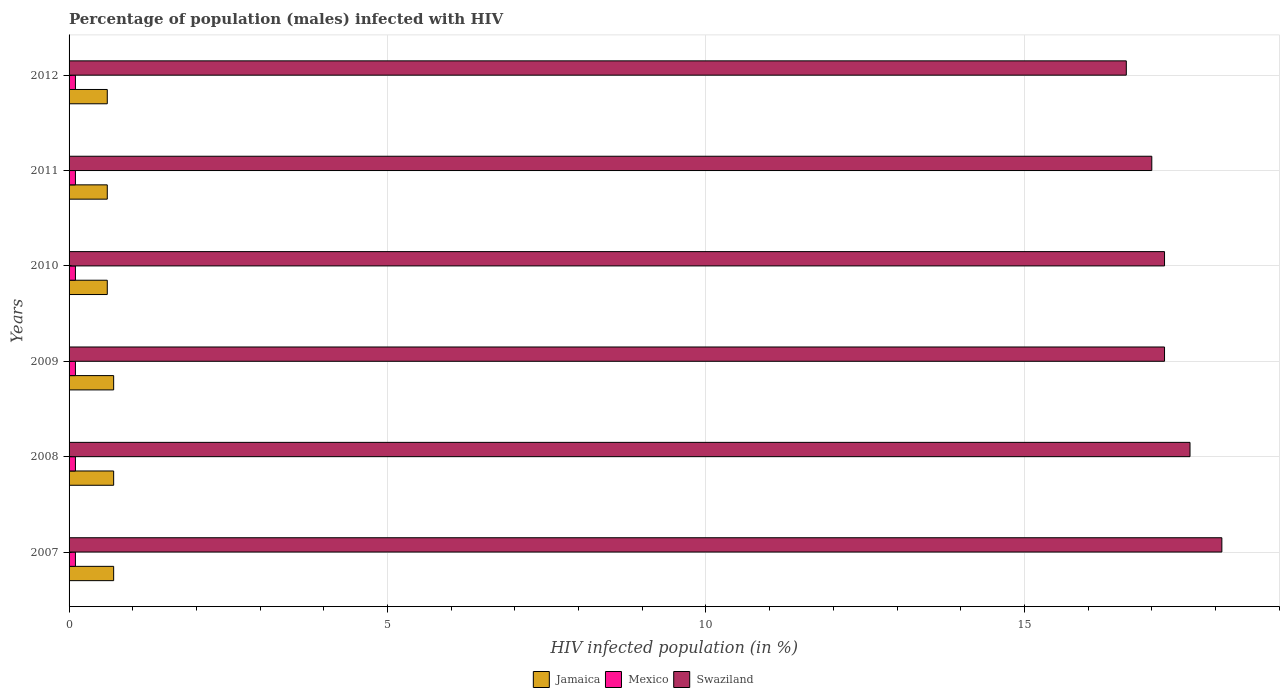How many different coloured bars are there?
Ensure brevity in your answer.  3. Are the number of bars per tick equal to the number of legend labels?
Your answer should be very brief. Yes. How many bars are there on the 2nd tick from the bottom?
Make the answer very short. 3. What is the label of the 5th group of bars from the top?
Offer a terse response. 2008. What is the percentage of HIV infected male population in Mexico in 2007?
Ensure brevity in your answer.  0.1. In which year was the percentage of HIV infected male population in Jamaica minimum?
Make the answer very short. 2010. What is the total percentage of HIV infected male population in Swaziland in the graph?
Make the answer very short. 103.7. What is the difference between the percentage of HIV infected male population in Swaziland in 2011 and that in 2012?
Keep it short and to the point. 0.4. What is the difference between the percentage of HIV infected male population in Jamaica in 2007 and the percentage of HIV infected male population in Mexico in 2012?
Give a very brief answer. 0.6. What is the average percentage of HIV infected male population in Jamaica per year?
Offer a very short reply. 0.65. In the year 2010, what is the difference between the percentage of HIV infected male population in Swaziland and percentage of HIV infected male population in Jamaica?
Ensure brevity in your answer.  16.6. What is the ratio of the percentage of HIV infected male population in Jamaica in 2009 to that in 2011?
Provide a succinct answer. 1.17. Is the percentage of HIV infected male population in Mexico in 2008 less than that in 2012?
Your answer should be very brief. No. Is the difference between the percentage of HIV infected male population in Swaziland in 2007 and 2009 greater than the difference between the percentage of HIV infected male population in Jamaica in 2007 and 2009?
Your response must be concise. Yes. What is the difference between the highest and the lowest percentage of HIV infected male population in Jamaica?
Provide a short and direct response. 0.1. In how many years, is the percentage of HIV infected male population in Swaziland greater than the average percentage of HIV infected male population in Swaziland taken over all years?
Offer a terse response. 2. What does the 3rd bar from the top in 2012 represents?
Ensure brevity in your answer.  Jamaica. What does the 3rd bar from the bottom in 2010 represents?
Give a very brief answer. Swaziland. Is it the case that in every year, the sum of the percentage of HIV infected male population in Swaziland and percentage of HIV infected male population in Mexico is greater than the percentage of HIV infected male population in Jamaica?
Offer a very short reply. Yes. Are all the bars in the graph horizontal?
Your answer should be very brief. Yes. What is the difference between two consecutive major ticks on the X-axis?
Provide a succinct answer. 5. Does the graph contain any zero values?
Keep it short and to the point. No. Does the graph contain grids?
Your answer should be very brief. Yes. What is the title of the graph?
Offer a very short reply. Percentage of population (males) infected with HIV. Does "Korea (Democratic)" appear as one of the legend labels in the graph?
Ensure brevity in your answer.  No. What is the label or title of the X-axis?
Keep it short and to the point. HIV infected population (in %). What is the HIV infected population (in %) in Jamaica in 2007?
Offer a very short reply. 0.7. What is the HIV infected population (in %) in Swaziland in 2007?
Provide a succinct answer. 18.1. What is the HIV infected population (in %) in Mexico in 2008?
Your answer should be compact. 0.1. What is the HIV infected population (in %) in Swaziland in 2008?
Provide a short and direct response. 17.6. What is the HIV infected population (in %) of Mexico in 2009?
Your answer should be very brief. 0.1. What is the HIV infected population (in %) of Jamaica in 2010?
Offer a terse response. 0.6. What is the HIV infected population (in %) in Swaziland in 2010?
Your answer should be compact. 17.2. What is the HIV infected population (in %) in Jamaica in 2011?
Keep it short and to the point. 0.6. What is the HIV infected population (in %) in Mexico in 2011?
Your answer should be compact. 0.1. What is the HIV infected population (in %) of Jamaica in 2012?
Offer a very short reply. 0.6. What is the HIV infected population (in %) in Mexico in 2012?
Your response must be concise. 0.1. Across all years, what is the maximum HIV infected population (in %) in Jamaica?
Your response must be concise. 0.7. Across all years, what is the maximum HIV infected population (in %) in Swaziland?
Provide a short and direct response. 18.1. Across all years, what is the minimum HIV infected population (in %) of Jamaica?
Ensure brevity in your answer.  0.6. Across all years, what is the minimum HIV infected population (in %) in Mexico?
Offer a terse response. 0.1. Across all years, what is the minimum HIV infected population (in %) of Swaziland?
Keep it short and to the point. 16.6. What is the total HIV infected population (in %) in Jamaica in the graph?
Make the answer very short. 3.9. What is the total HIV infected population (in %) of Mexico in the graph?
Provide a short and direct response. 0.6. What is the total HIV infected population (in %) of Swaziland in the graph?
Give a very brief answer. 103.7. What is the difference between the HIV infected population (in %) in Mexico in 2007 and that in 2008?
Your response must be concise. 0. What is the difference between the HIV infected population (in %) of Swaziland in 2007 and that in 2009?
Make the answer very short. 0.9. What is the difference between the HIV infected population (in %) in Jamaica in 2007 and that in 2010?
Give a very brief answer. 0.1. What is the difference between the HIV infected population (in %) in Jamaica in 2007 and that in 2012?
Keep it short and to the point. 0.1. What is the difference between the HIV infected population (in %) of Swaziland in 2008 and that in 2009?
Your answer should be very brief. 0.4. What is the difference between the HIV infected population (in %) in Mexico in 2008 and that in 2010?
Offer a very short reply. 0. What is the difference between the HIV infected population (in %) of Swaziland in 2008 and that in 2010?
Your answer should be very brief. 0.4. What is the difference between the HIV infected population (in %) in Jamaica in 2008 and that in 2011?
Offer a terse response. 0.1. What is the difference between the HIV infected population (in %) in Mexico in 2008 and that in 2011?
Keep it short and to the point. 0. What is the difference between the HIV infected population (in %) in Jamaica in 2008 and that in 2012?
Give a very brief answer. 0.1. What is the difference between the HIV infected population (in %) of Mexico in 2008 and that in 2012?
Keep it short and to the point. 0. What is the difference between the HIV infected population (in %) of Swaziland in 2009 and that in 2010?
Provide a short and direct response. 0. What is the difference between the HIV infected population (in %) in Jamaica in 2009 and that in 2011?
Offer a terse response. 0.1. What is the difference between the HIV infected population (in %) of Swaziland in 2009 and that in 2011?
Ensure brevity in your answer.  0.2. What is the difference between the HIV infected population (in %) in Mexico in 2010 and that in 2011?
Offer a terse response. 0. What is the difference between the HIV infected population (in %) of Swaziland in 2010 and that in 2011?
Your answer should be compact. 0.2. What is the difference between the HIV infected population (in %) in Jamaica in 2010 and that in 2012?
Provide a short and direct response. 0. What is the difference between the HIV infected population (in %) of Swaziland in 2010 and that in 2012?
Give a very brief answer. 0.6. What is the difference between the HIV infected population (in %) in Jamaica in 2011 and that in 2012?
Ensure brevity in your answer.  0. What is the difference between the HIV infected population (in %) of Jamaica in 2007 and the HIV infected population (in %) of Mexico in 2008?
Offer a very short reply. 0.6. What is the difference between the HIV infected population (in %) in Jamaica in 2007 and the HIV infected population (in %) in Swaziland in 2008?
Your response must be concise. -16.9. What is the difference between the HIV infected population (in %) in Mexico in 2007 and the HIV infected population (in %) in Swaziland in 2008?
Make the answer very short. -17.5. What is the difference between the HIV infected population (in %) in Jamaica in 2007 and the HIV infected population (in %) in Swaziland in 2009?
Ensure brevity in your answer.  -16.5. What is the difference between the HIV infected population (in %) of Mexico in 2007 and the HIV infected population (in %) of Swaziland in 2009?
Offer a very short reply. -17.1. What is the difference between the HIV infected population (in %) in Jamaica in 2007 and the HIV infected population (in %) in Mexico in 2010?
Keep it short and to the point. 0.6. What is the difference between the HIV infected population (in %) of Jamaica in 2007 and the HIV infected population (in %) of Swaziland in 2010?
Give a very brief answer. -16.5. What is the difference between the HIV infected population (in %) in Mexico in 2007 and the HIV infected population (in %) in Swaziland in 2010?
Provide a succinct answer. -17.1. What is the difference between the HIV infected population (in %) of Jamaica in 2007 and the HIV infected population (in %) of Mexico in 2011?
Your response must be concise. 0.6. What is the difference between the HIV infected population (in %) in Jamaica in 2007 and the HIV infected population (in %) in Swaziland in 2011?
Keep it short and to the point. -16.3. What is the difference between the HIV infected population (in %) in Mexico in 2007 and the HIV infected population (in %) in Swaziland in 2011?
Offer a very short reply. -16.9. What is the difference between the HIV infected population (in %) of Jamaica in 2007 and the HIV infected population (in %) of Mexico in 2012?
Give a very brief answer. 0.6. What is the difference between the HIV infected population (in %) of Jamaica in 2007 and the HIV infected population (in %) of Swaziland in 2012?
Make the answer very short. -15.9. What is the difference between the HIV infected population (in %) of Mexico in 2007 and the HIV infected population (in %) of Swaziland in 2012?
Your answer should be very brief. -16.5. What is the difference between the HIV infected population (in %) in Jamaica in 2008 and the HIV infected population (in %) in Swaziland in 2009?
Offer a very short reply. -16.5. What is the difference between the HIV infected population (in %) of Mexico in 2008 and the HIV infected population (in %) of Swaziland in 2009?
Keep it short and to the point. -17.1. What is the difference between the HIV infected population (in %) in Jamaica in 2008 and the HIV infected population (in %) in Mexico in 2010?
Ensure brevity in your answer.  0.6. What is the difference between the HIV infected population (in %) of Jamaica in 2008 and the HIV infected population (in %) of Swaziland in 2010?
Offer a very short reply. -16.5. What is the difference between the HIV infected population (in %) of Mexico in 2008 and the HIV infected population (in %) of Swaziland in 2010?
Provide a short and direct response. -17.1. What is the difference between the HIV infected population (in %) in Jamaica in 2008 and the HIV infected population (in %) in Swaziland in 2011?
Offer a very short reply. -16.3. What is the difference between the HIV infected population (in %) of Mexico in 2008 and the HIV infected population (in %) of Swaziland in 2011?
Give a very brief answer. -16.9. What is the difference between the HIV infected population (in %) in Jamaica in 2008 and the HIV infected population (in %) in Swaziland in 2012?
Offer a very short reply. -15.9. What is the difference between the HIV infected population (in %) of Mexico in 2008 and the HIV infected population (in %) of Swaziland in 2012?
Offer a terse response. -16.5. What is the difference between the HIV infected population (in %) in Jamaica in 2009 and the HIV infected population (in %) in Swaziland in 2010?
Keep it short and to the point. -16.5. What is the difference between the HIV infected population (in %) in Mexico in 2009 and the HIV infected population (in %) in Swaziland in 2010?
Your response must be concise. -17.1. What is the difference between the HIV infected population (in %) of Jamaica in 2009 and the HIV infected population (in %) of Mexico in 2011?
Provide a short and direct response. 0.6. What is the difference between the HIV infected population (in %) of Jamaica in 2009 and the HIV infected population (in %) of Swaziland in 2011?
Provide a succinct answer. -16.3. What is the difference between the HIV infected population (in %) in Mexico in 2009 and the HIV infected population (in %) in Swaziland in 2011?
Offer a terse response. -16.9. What is the difference between the HIV infected population (in %) of Jamaica in 2009 and the HIV infected population (in %) of Swaziland in 2012?
Your response must be concise. -15.9. What is the difference between the HIV infected population (in %) in Mexico in 2009 and the HIV infected population (in %) in Swaziland in 2012?
Make the answer very short. -16.5. What is the difference between the HIV infected population (in %) in Jamaica in 2010 and the HIV infected population (in %) in Swaziland in 2011?
Your answer should be very brief. -16.4. What is the difference between the HIV infected population (in %) of Mexico in 2010 and the HIV infected population (in %) of Swaziland in 2011?
Ensure brevity in your answer.  -16.9. What is the difference between the HIV infected population (in %) in Mexico in 2010 and the HIV infected population (in %) in Swaziland in 2012?
Provide a short and direct response. -16.5. What is the difference between the HIV infected population (in %) of Jamaica in 2011 and the HIV infected population (in %) of Mexico in 2012?
Your answer should be very brief. 0.5. What is the difference between the HIV infected population (in %) in Mexico in 2011 and the HIV infected population (in %) in Swaziland in 2012?
Make the answer very short. -16.5. What is the average HIV infected population (in %) of Jamaica per year?
Give a very brief answer. 0.65. What is the average HIV infected population (in %) in Swaziland per year?
Offer a very short reply. 17.28. In the year 2007, what is the difference between the HIV infected population (in %) in Jamaica and HIV infected population (in %) in Swaziland?
Offer a very short reply. -17.4. In the year 2007, what is the difference between the HIV infected population (in %) in Mexico and HIV infected population (in %) in Swaziland?
Keep it short and to the point. -18. In the year 2008, what is the difference between the HIV infected population (in %) of Jamaica and HIV infected population (in %) of Swaziland?
Ensure brevity in your answer.  -16.9. In the year 2008, what is the difference between the HIV infected population (in %) in Mexico and HIV infected population (in %) in Swaziland?
Provide a short and direct response. -17.5. In the year 2009, what is the difference between the HIV infected population (in %) of Jamaica and HIV infected population (in %) of Swaziland?
Your answer should be compact. -16.5. In the year 2009, what is the difference between the HIV infected population (in %) of Mexico and HIV infected population (in %) of Swaziland?
Provide a succinct answer. -17.1. In the year 2010, what is the difference between the HIV infected population (in %) of Jamaica and HIV infected population (in %) of Swaziland?
Make the answer very short. -16.6. In the year 2010, what is the difference between the HIV infected population (in %) in Mexico and HIV infected population (in %) in Swaziland?
Make the answer very short. -17.1. In the year 2011, what is the difference between the HIV infected population (in %) of Jamaica and HIV infected population (in %) of Swaziland?
Give a very brief answer. -16.4. In the year 2011, what is the difference between the HIV infected population (in %) in Mexico and HIV infected population (in %) in Swaziland?
Your answer should be very brief. -16.9. In the year 2012, what is the difference between the HIV infected population (in %) of Jamaica and HIV infected population (in %) of Mexico?
Make the answer very short. 0.5. In the year 2012, what is the difference between the HIV infected population (in %) of Jamaica and HIV infected population (in %) of Swaziland?
Provide a succinct answer. -16. In the year 2012, what is the difference between the HIV infected population (in %) in Mexico and HIV infected population (in %) in Swaziland?
Offer a very short reply. -16.5. What is the ratio of the HIV infected population (in %) of Jamaica in 2007 to that in 2008?
Make the answer very short. 1. What is the ratio of the HIV infected population (in %) of Mexico in 2007 to that in 2008?
Ensure brevity in your answer.  1. What is the ratio of the HIV infected population (in %) in Swaziland in 2007 to that in 2008?
Keep it short and to the point. 1.03. What is the ratio of the HIV infected population (in %) of Jamaica in 2007 to that in 2009?
Your answer should be compact. 1. What is the ratio of the HIV infected population (in %) in Mexico in 2007 to that in 2009?
Provide a succinct answer. 1. What is the ratio of the HIV infected population (in %) of Swaziland in 2007 to that in 2009?
Offer a very short reply. 1.05. What is the ratio of the HIV infected population (in %) in Mexico in 2007 to that in 2010?
Ensure brevity in your answer.  1. What is the ratio of the HIV infected population (in %) in Swaziland in 2007 to that in 2010?
Keep it short and to the point. 1.05. What is the ratio of the HIV infected population (in %) in Jamaica in 2007 to that in 2011?
Provide a succinct answer. 1.17. What is the ratio of the HIV infected population (in %) of Swaziland in 2007 to that in 2011?
Provide a short and direct response. 1.06. What is the ratio of the HIV infected population (in %) in Jamaica in 2007 to that in 2012?
Offer a very short reply. 1.17. What is the ratio of the HIV infected population (in %) in Swaziland in 2007 to that in 2012?
Ensure brevity in your answer.  1.09. What is the ratio of the HIV infected population (in %) of Jamaica in 2008 to that in 2009?
Offer a terse response. 1. What is the ratio of the HIV infected population (in %) of Swaziland in 2008 to that in 2009?
Provide a succinct answer. 1.02. What is the ratio of the HIV infected population (in %) of Swaziland in 2008 to that in 2010?
Make the answer very short. 1.02. What is the ratio of the HIV infected population (in %) in Jamaica in 2008 to that in 2011?
Offer a very short reply. 1.17. What is the ratio of the HIV infected population (in %) in Mexico in 2008 to that in 2011?
Offer a terse response. 1. What is the ratio of the HIV infected population (in %) in Swaziland in 2008 to that in 2011?
Provide a short and direct response. 1.04. What is the ratio of the HIV infected population (in %) of Jamaica in 2008 to that in 2012?
Offer a very short reply. 1.17. What is the ratio of the HIV infected population (in %) of Swaziland in 2008 to that in 2012?
Keep it short and to the point. 1.06. What is the ratio of the HIV infected population (in %) of Jamaica in 2009 to that in 2010?
Make the answer very short. 1.17. What is the ratio of the HIV infected population (in %) in Swaziland in 2009 to that in 2011?
Give a very brief answer. 1.01. What is the ratio of the HIV infected population (in %) of Swaziland in 2009 to that in 2012?
Make the answer very short. 1.04. What is the ratio of the HIV infected population (in %) of Swaziland in 2010 to that in 2011?
Offer a terse response. 1.01. What is the ratio of the HIV infected population (in %) in Jamaica in 2010 to that in 2012?
Your response must be concise. 1. What is the ratio of the HIV infected population (in %) of Mexico in 2010 to that in 2012?
Give a very brief answer. 1. What is the ratio of the HIV infected population (in %) of Swaziland in 2010 to that in 2012?
Ensure brevity in your answer.  1.04. What is the ratio of the HIV infected population (in %) of Mexico in 2011 to that in 2012?
Provide a short and direct response. 1. What is the ratio of the HIV infected population (in %) of Swaziland in 2011 to that in 2012?
Your answer should be compact. 1.02. What is the difference between the highest and the second highest HIV infected population (in %) of Jamaica?
Give a very brief answer. 0. What is the difference between the highest and the second highest HIV infected population (in %) of Swaziland?
Keep it short and to the point. 0.5. What is the difference between the highest and the lowest HIV infected population (in %) in Swaziland?
Provide a succinct answer. 1.5. 